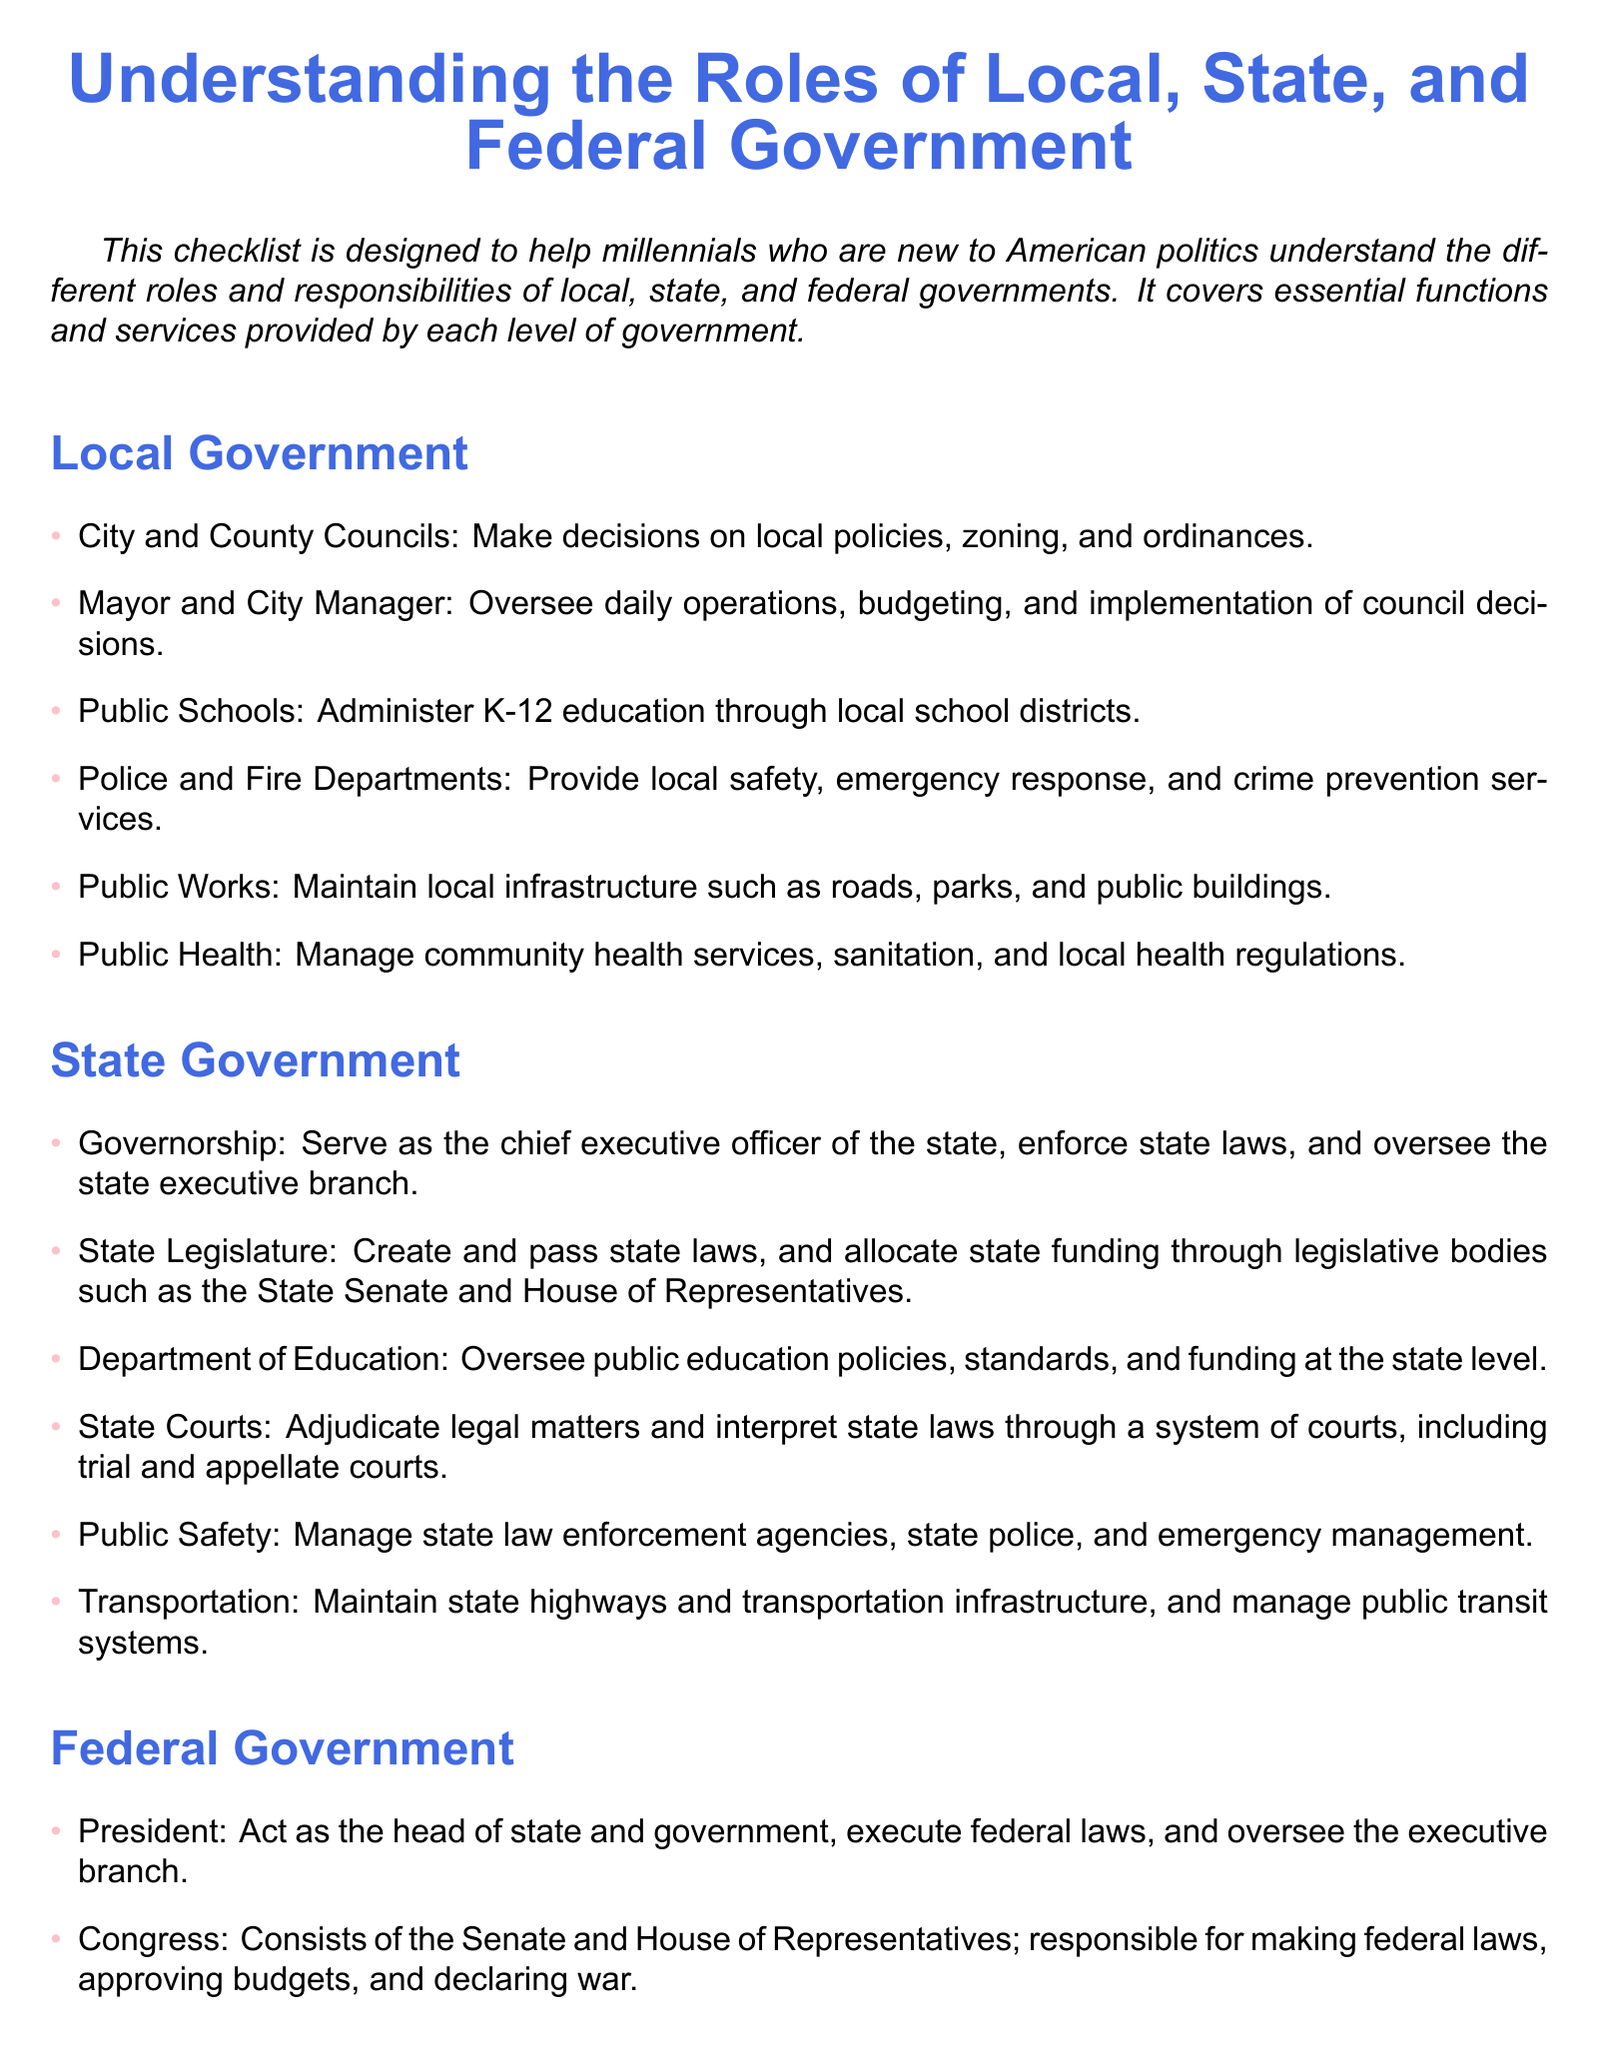What is the role of city and county councils? City and County Councils make decisions on local policies, zoning, and ordinances.
Answer: local policies, zoning, and ordinances Who oversees public education at the state level? The Department of Education oversees public education policies, standards, and funding at the state level.
Answer: Department of Education What does the President act as? The President acts as the head of state and government.
Answer: head of state and government Which level of government is responsible for managing state highways? The State Government is responsible for maintaining state highways and transportation infrastructure.
Answer: State Government What is one function of local public health? Public health manages community health services, sanitation, and local health regulations.
Answer: community health services, sanitation, and local health regulations What are the two bodies that make up Congress? Congress consists of the Senate and House of Representatives.
Answer: Senate and House of Representatives What is the purpose of state courts? State Courts adjudicate legal matters and interpret state laws.
Answer: adjudicate legal matters and interpret state laws Which federal agency deals with environmental issues? The Environmental Protection Agency (EPA) implements federal laws and regulations regarding environmental issues.
Answer: Environmental Protection Agency (EPA) What is a key service provided by local police departments? Local police departments provide safety, emergency response, and crime prevention services.
Answer: safety, emergency response, and crime prevention services 